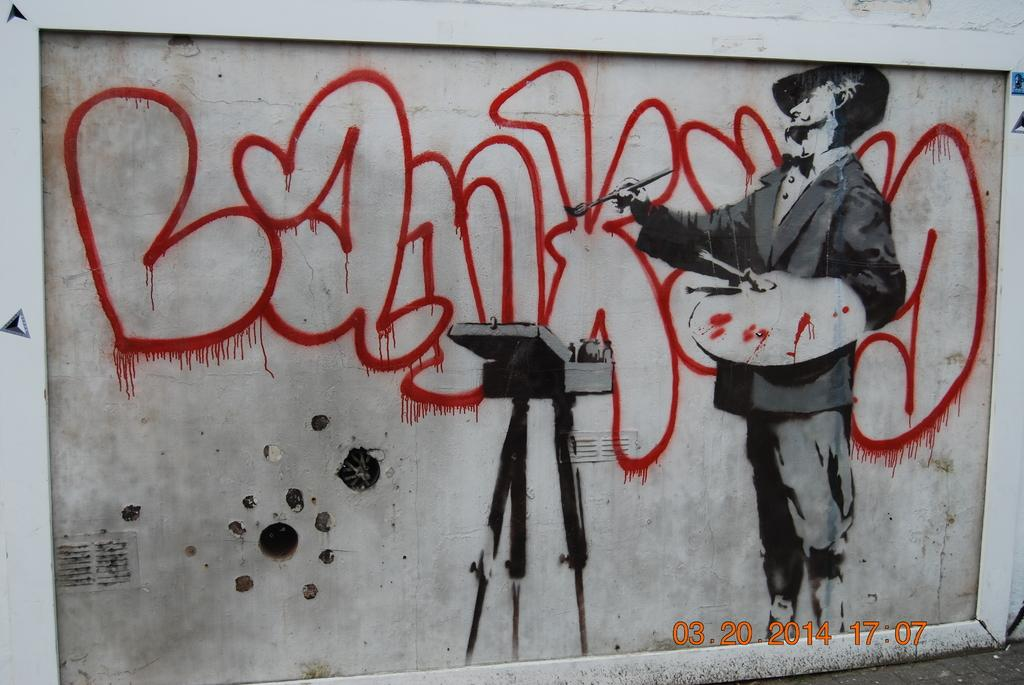What is the main feature of the picture? The main feature of the picture is a surface with a painting on it. What is shown in the painting? The painting depicts a man writing something. Can you describe the subject matter of the painting? The painting shows a man engaged in the act of writing. What type of bottle is being used by the man in the painting to increase his profit? There is no bottle or mention of profit in the painting; it simply depicts a man writing something. 